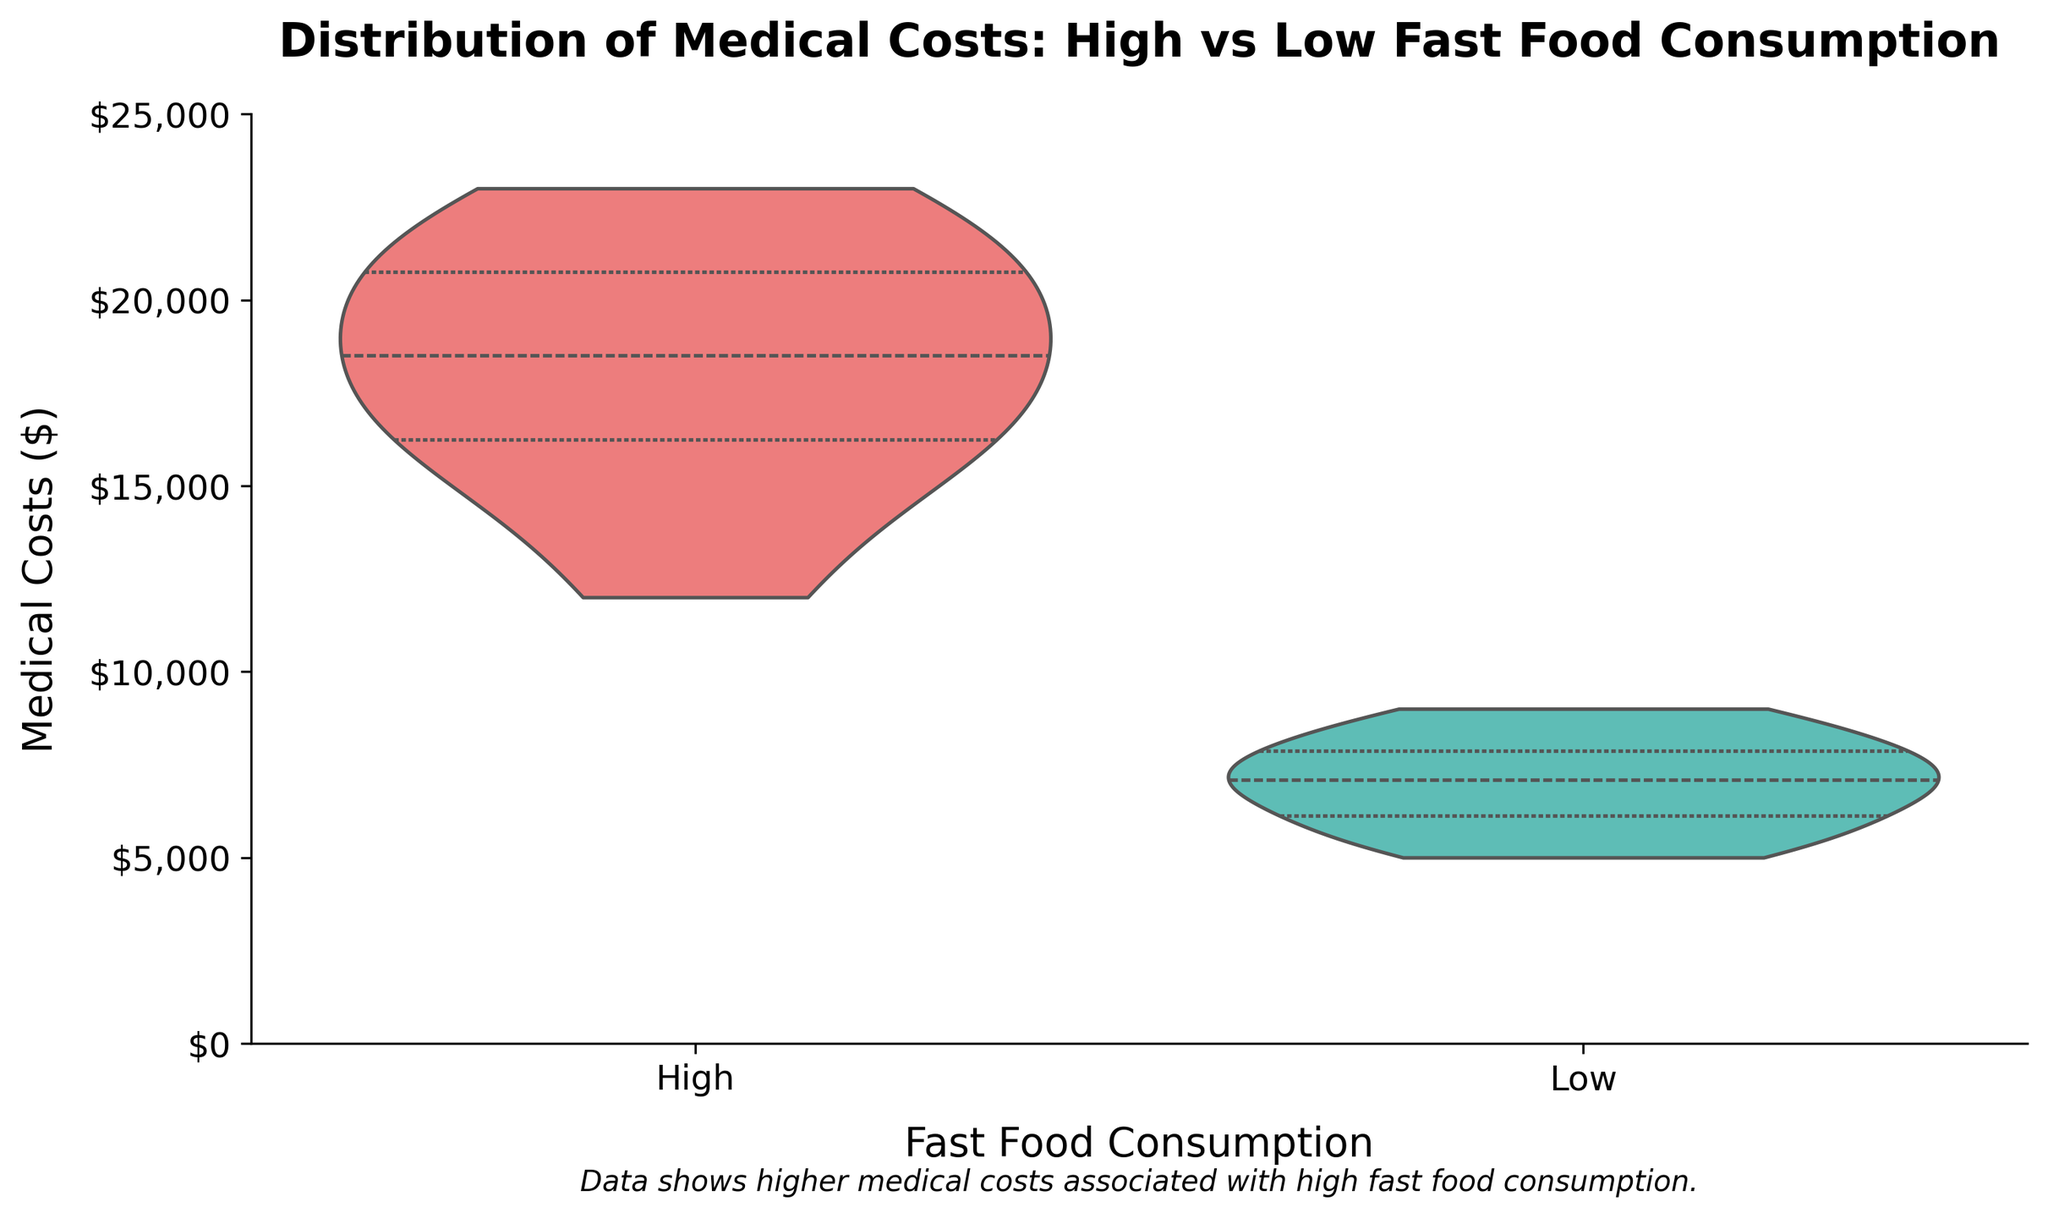How are the "Fast Food Consumption" categories labeled on the x-axis? The x-axis shows two categories representing different levels of fast food consumption: 'High' and 'Low'.
Answer: High and Low What is the y-axis range for Medical Costs? The y-axis ranges from $0 to $25,000.
Answer: $0 to $25,000 Which fast food consumption group has the highest median medical costs? The median is indicated by the white dot within the violin plot. The group 'High' has a higher median medical cost compared to the 'Low' group.
Answer: High What is the approximate range of medical costs for the 'Low' fast food consumption group? The 'Low' group has medical costs ranging roughly from $5,000 to $9,000 as shown by the length of the violin plot.
Answer: $5,000 to $9,000 Compare the spread of medical costs between the 'High' and 'Low' fast food consumption groups. The spread of medical costs for the 'High' group is wider, showing greater variability (from about $12,000 to $23,000), whereas the 'Low' group's costs are more narrowly distributed (from about $5,000 to $9,000).
Answer: 'High' group has a wider spread What is the title of the violin plot? The plot is titled "Distribution of Medical Costs: High vs Low Fast Food Consumption".
Answer: Distribution of Medical Costs: High vs Low Fast Food Consumption What does the text below the x-axis state about medical costs? The text mentions that the data shows higher medical costs associated with high fast food consumption.
Answer: Higher medical costs associated with high fast food consumption How does the upper quartile of the 'High' consumption group compare to the maximum of the 'Low' consumption group? The upper quartile of the 'High' consumption group is above the maximum value of the 'Low' consumption group, which means the top 25% of people with high fast food consumption have medical costs higher than the highest costs in the low consumption group.
Answer: Higher Do the 'High' and 'Low' group distributions have any overlap in medical costs? There appears to be no overlap in medical costs; the lowest costs in the 'High' group are still higher than the highest costs in the 'Low' group.
Answer: No overlap 